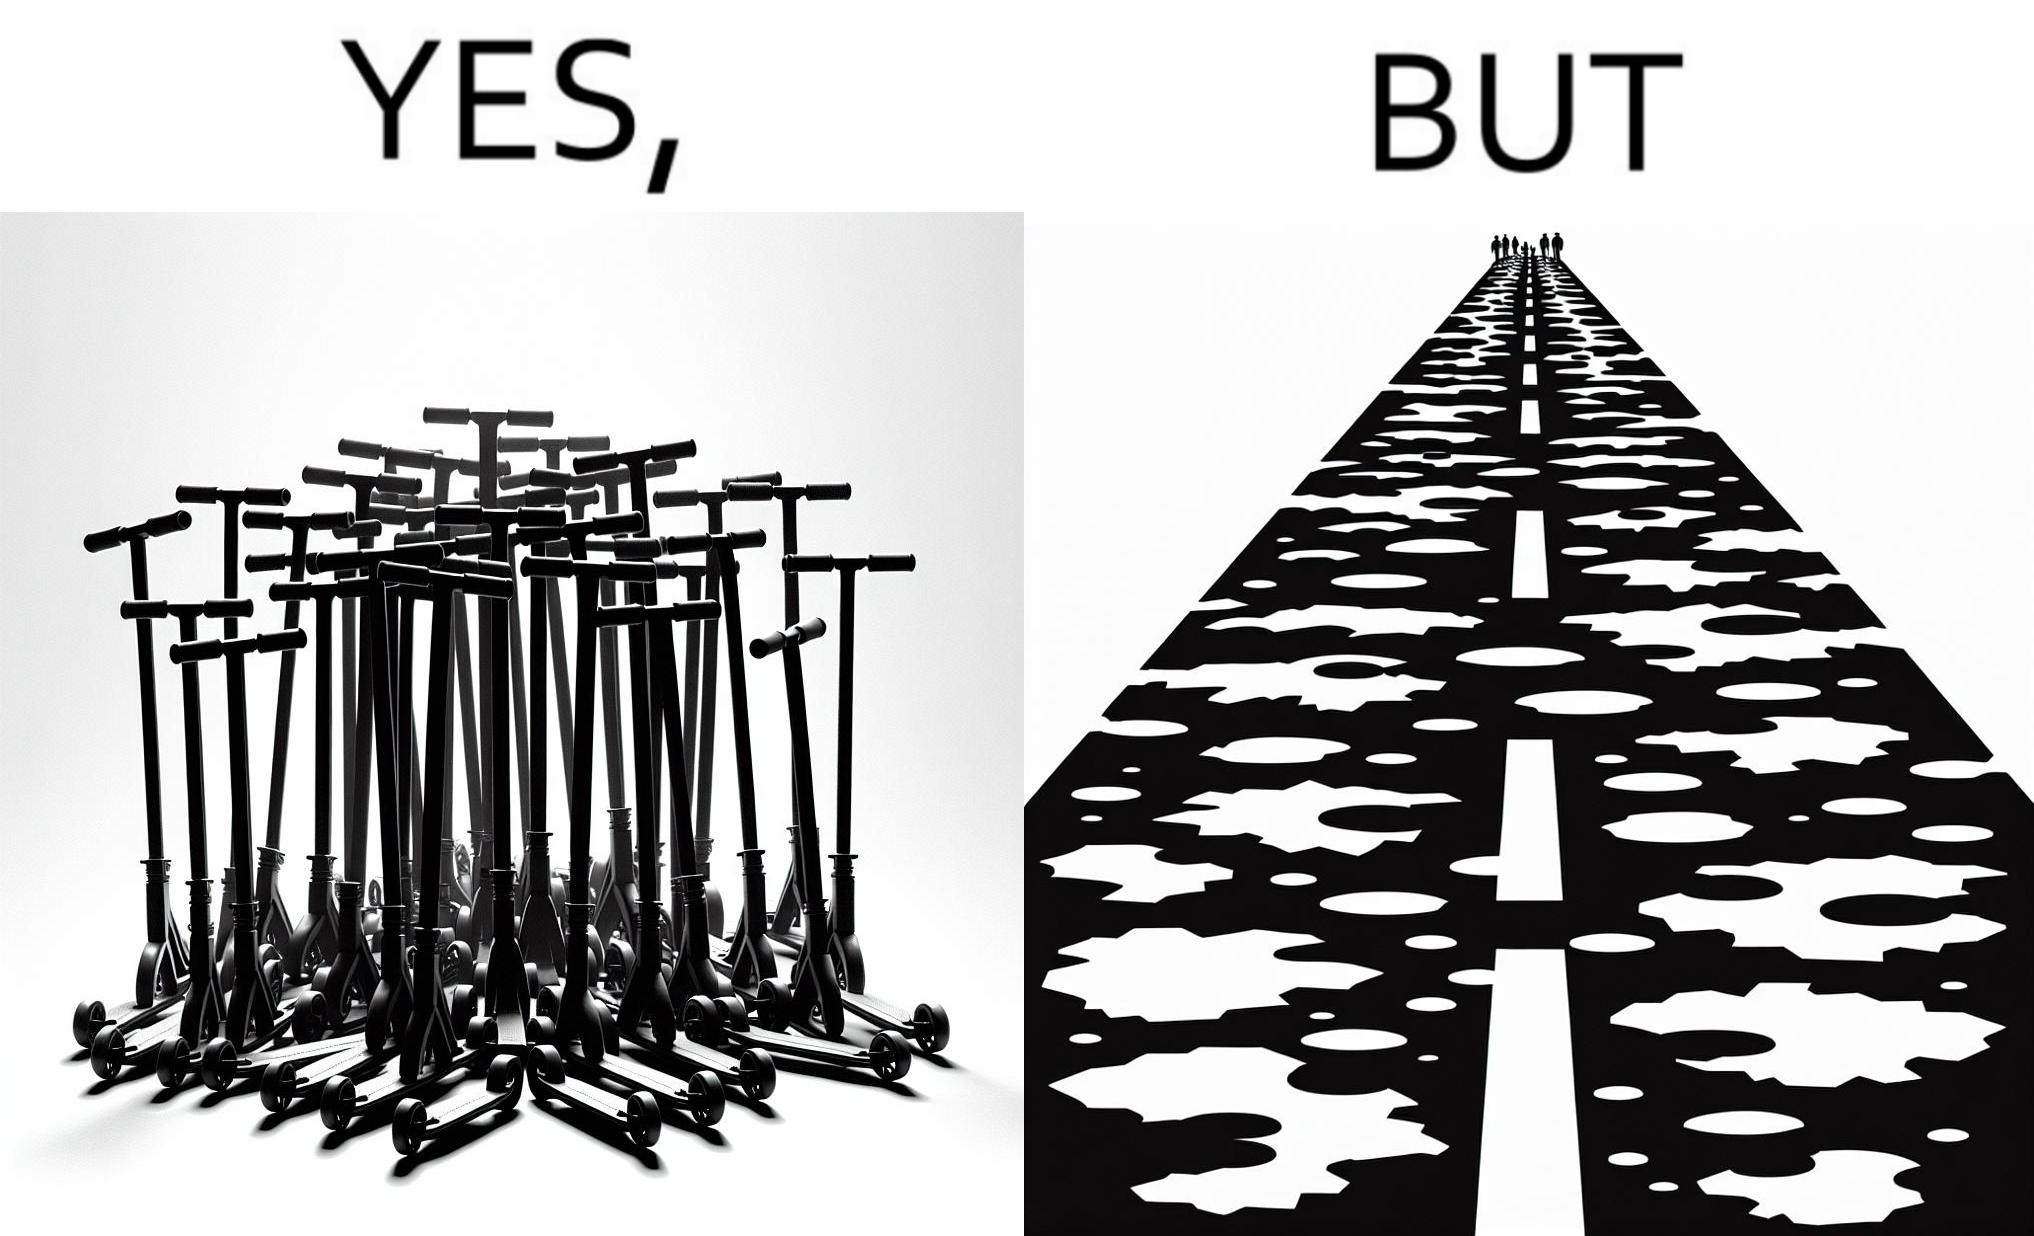Is this image satirical or non-satirical? Yes, this image is satirical. 